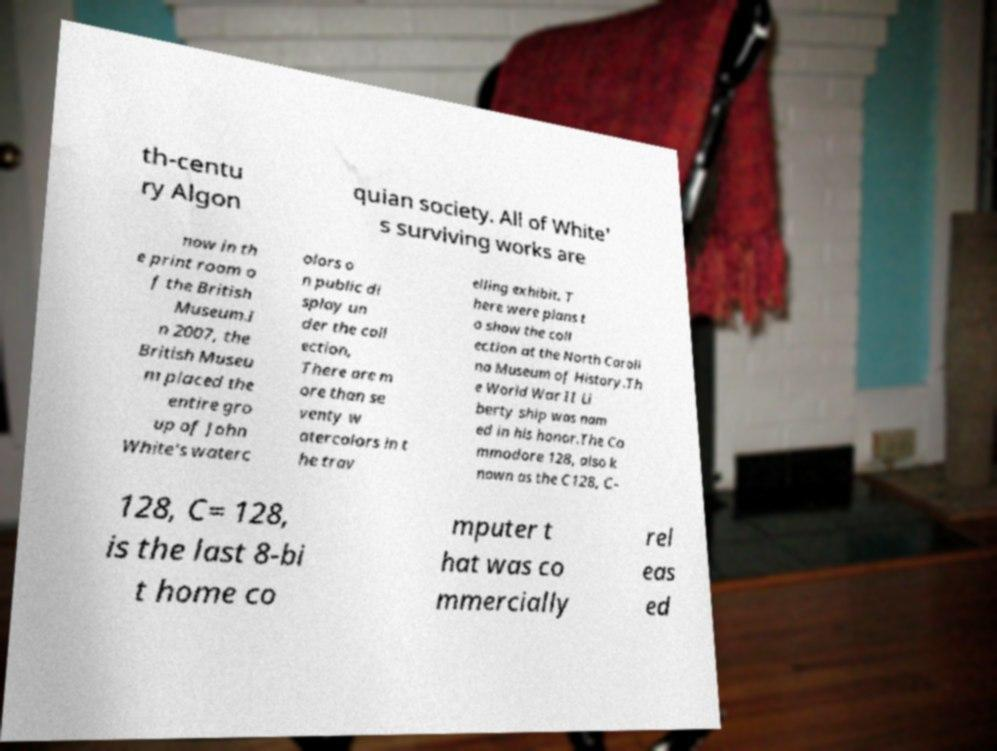Please identify and transcribe the text found in this image. th-centu ry Algon quian society. All of White' s surviving works are now in th e print room o f the British Museum.I n 2007, the British Museu m placed the entire gro up of John White's waterc olors o n public di splay un der the coll ection, There are m ore than se venty w atercolors in t he trav elling exhibit. T here were plans t o show the coll ection at the North Caroli na Museum of History.Th e World War II Li berty ship was nam ed in his honor.The Co mmodore 128, also k nown as the C128, C- 128, C= 128, is the last 8-bi t home co mputer t hat was co mmercially rel eas ed 